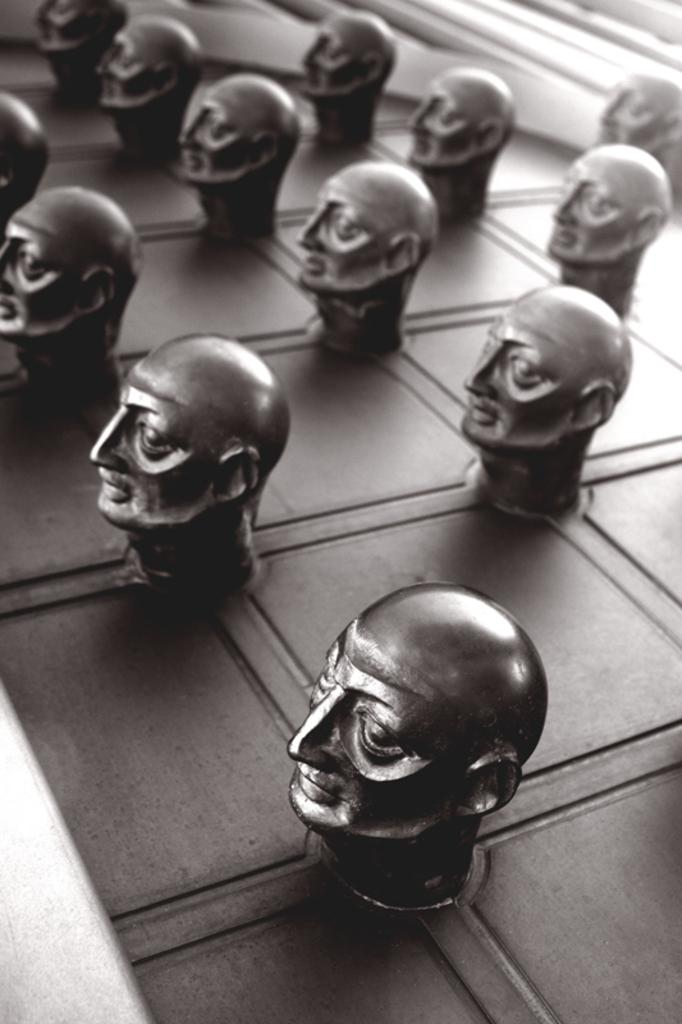What type of objects can be seen in the image? There are sculptures in the image. What is the color scheme of the image? The image is black and white in color. What type of beef is being served in the image? There is no beef present in the image; it features sculptures in a black and white color scheme. How many goldfish can be seen swimming in the image? There are no goldfish present in the image; it features sculptures in a black and white color scheme. 